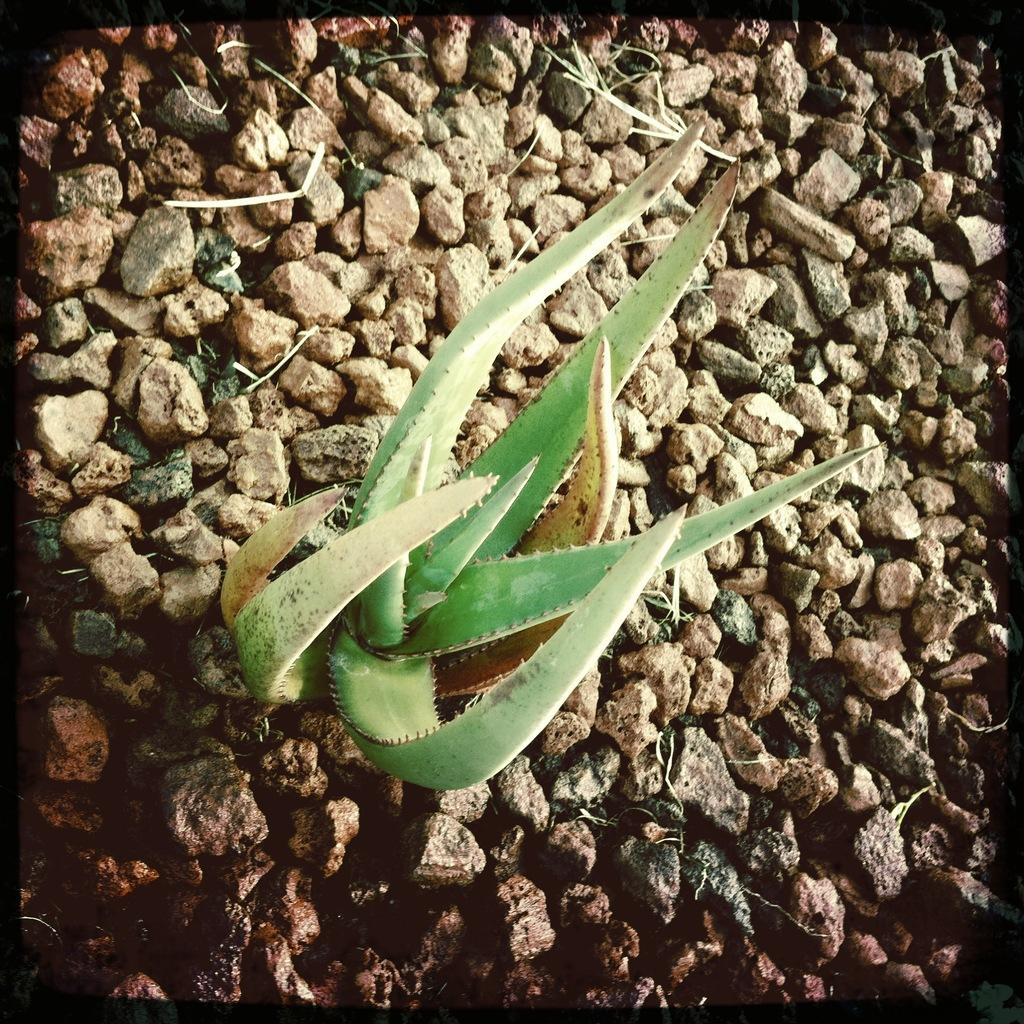What type of plant is in the image? There is an aloe vera plant in the image. How is the aloe vera plant positioned in the image? The aloe vera plant is situated between stones. How many visitors can be seen playing on the playground in the image? There is no playground or visitors present in the image; it features an aloe vera plant situated between stones. What is the sister of the aloe vera plant doing in the image? There is no mention of a sister plant or any other plants in the image; it only features the aloe vera plant. 